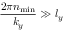<formula> <loc_0><loc_0><loc_500><loc_500>\frac { 2 \pi n _ { \min } } { k _ { y } } \gg l _ { y }</formula> 